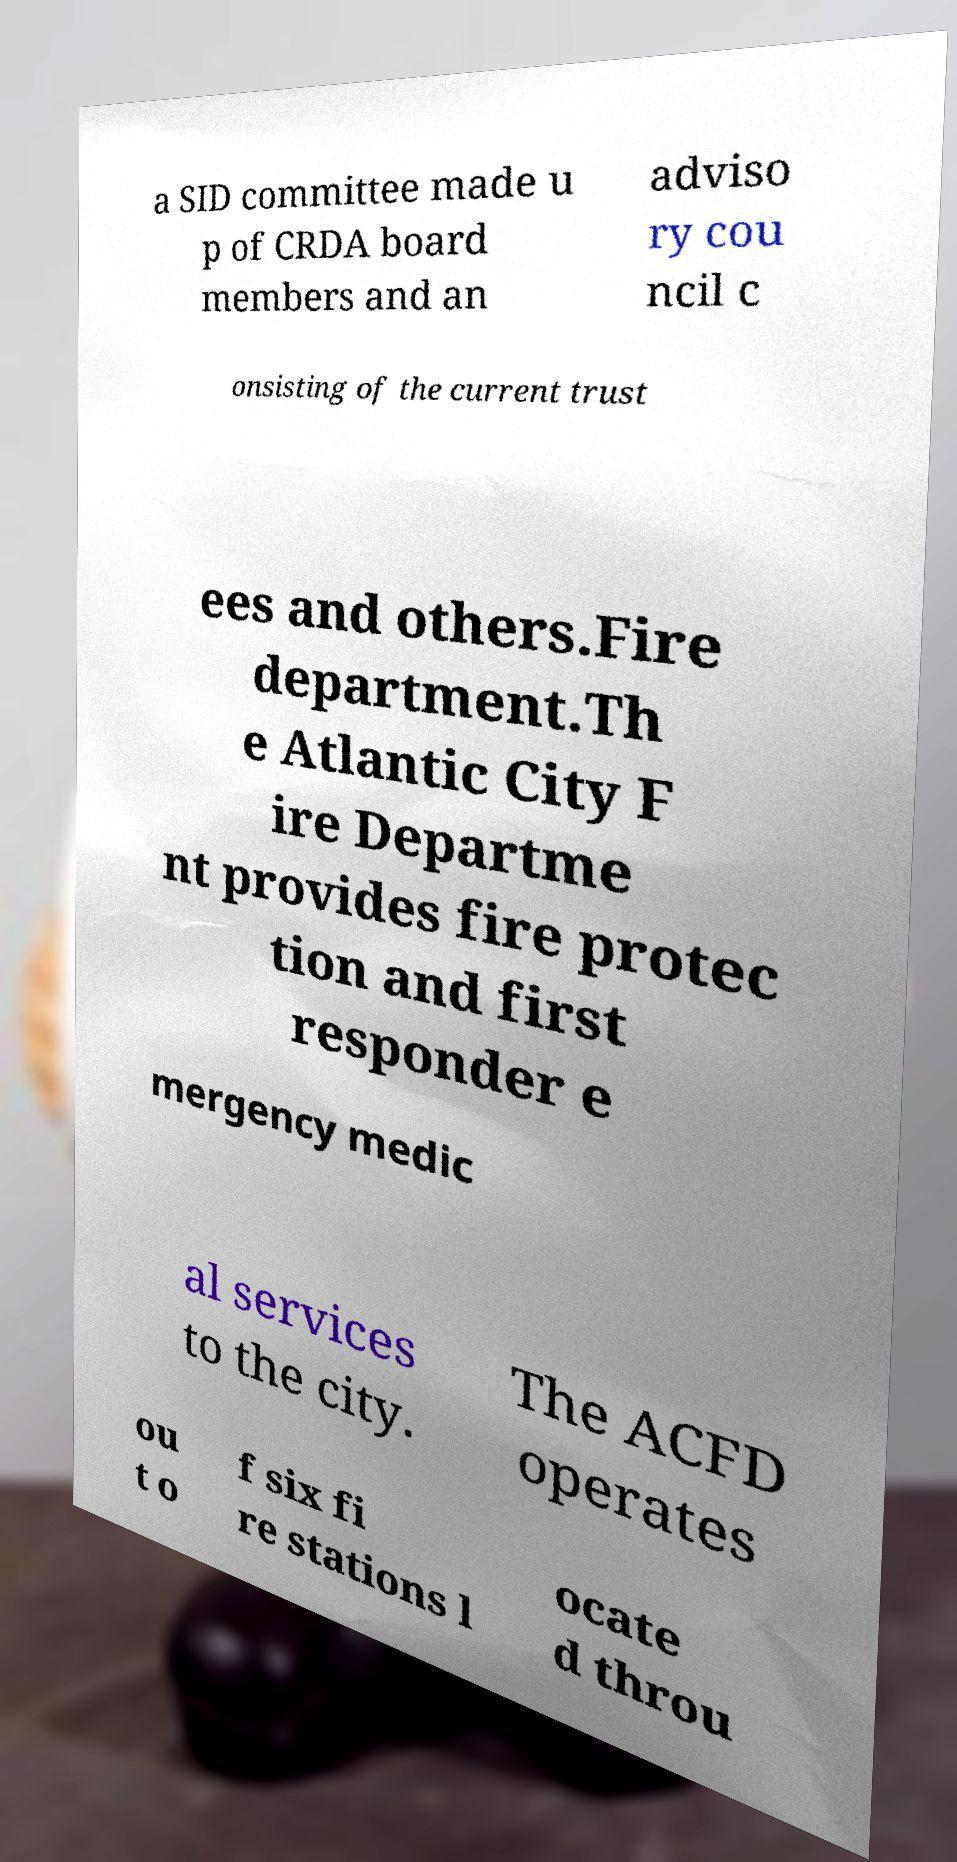There's text embedded in this image that I need extracted. Can you transcribe it verbatim? a SID committee made u p of CRDA board members and an adviso ry cou ncil c onsisting of the current trust ees and others.Fire department.Th e Atlantic City F ire Departme nt provides fire protec tion and first responder e mergency medic al services to the city. The ACFD operates ou t o f six fi re stations l ocate d throu 